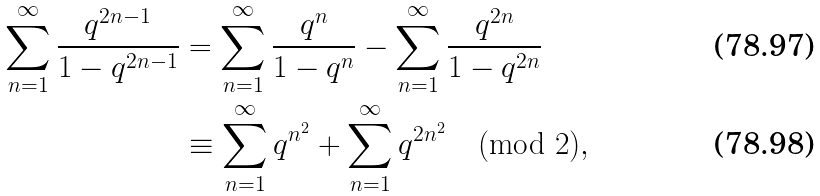<formula> <loc_0><loc_0><loc_500><loc_500>\sum _ { n = 1 } ^ { \infty } \frac { q ^ { 2 n - 1 } } { 1 - q ^ { 2 n - 1 } } & = \sum _ { n = 1 } ^ { \infty } \frac { q ^ { n } } { 1 - q ^ { n } } - \sum _ { n = 1 } ^ { \infty } \frac { q ^ { 2 n } } { 1 - q ^ { 2 n } } \\ & \equiv \sum _ { n = 1 } ^ { \infty } q ^ { n ^ { 2 } } + \sum _ { n = 1 } ^ { \infty } q ^ { 2 n ^ { 2 } } \pmod { 2 } ,</formula> 